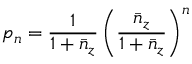<formula> <loc_0><loc_0><loc_500><loc_500>p _ { n } = \frac { 1 } { 1 + \bar { n } _ { z } } \left ( \frac { \bar { n } _ { z } } { 1 + \bar { n } _ { z } } \right ) ^ { n }</formula> 